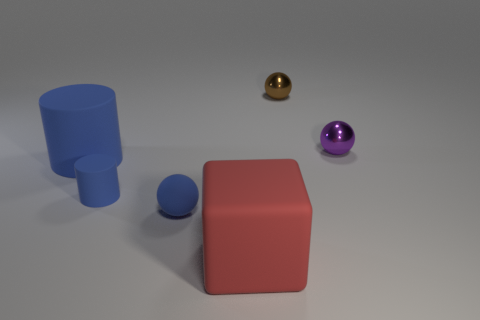Add 3 big matte blocks. How many objects exist? 9 Subtract all cubes. How many objects are left? 5 Subtract all red objects. Subtract all tiny green metal blocks. How many objects are left? 5 Add 3 tiny blue things. How many tiny blue things are left? 5 Add 4 large blue things. How many large blue things exist? 5 Subtract 0 yellow cylinders. How many objects are left? 6 